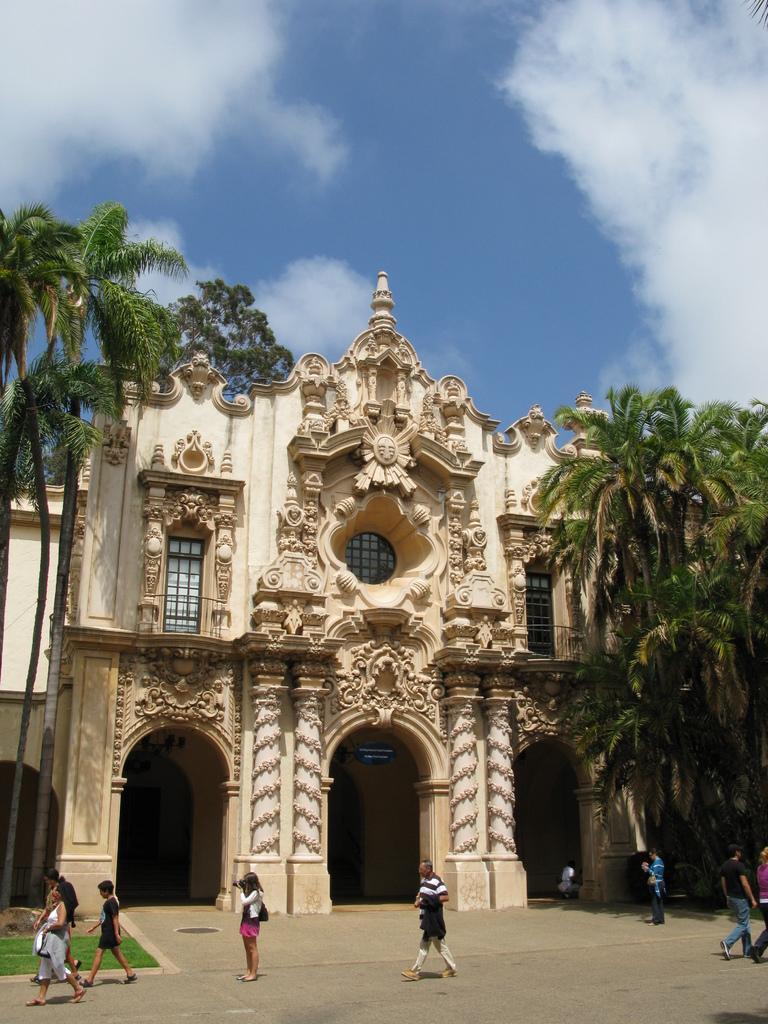Can you describe this image briefly? In this image I can see the group of people with different color dresses. To the side of these people I can see the cream color building and many trees. In the background I can see the clouds and the blue sky. 